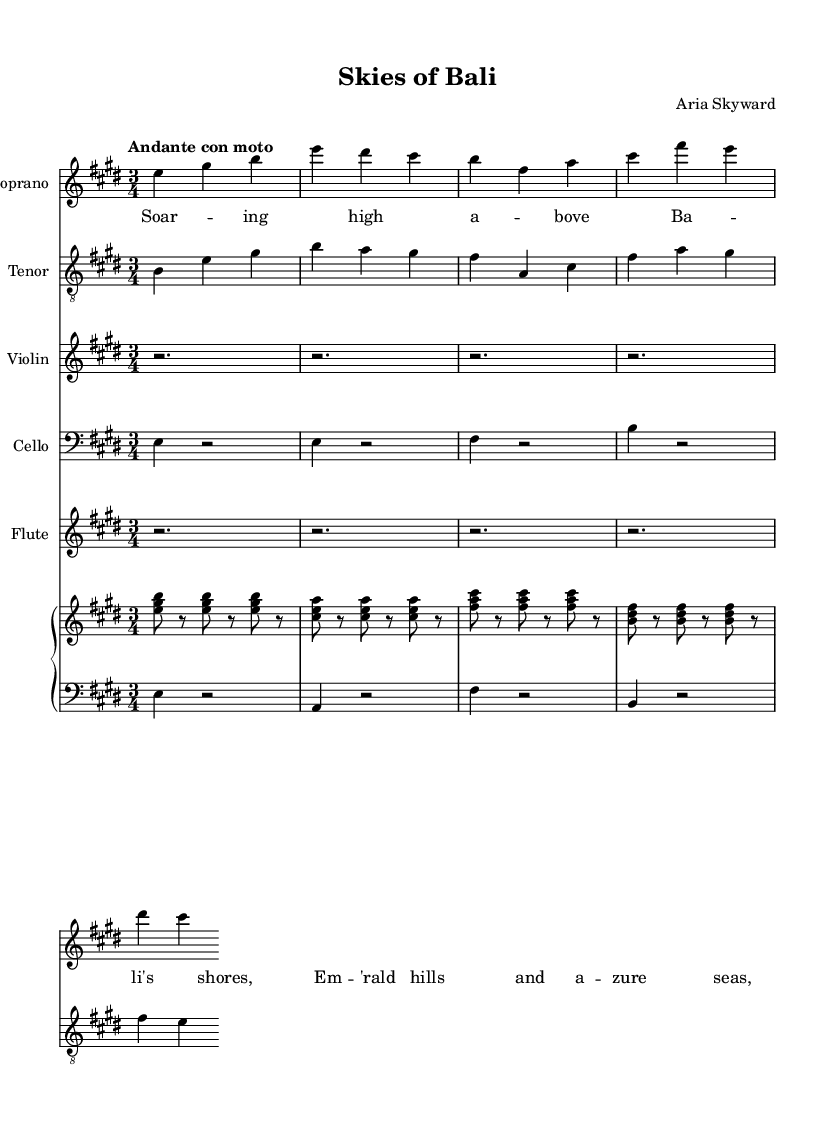What is the key signature of this music? The key signature is E major, which has four sharps (F#, C#, G#, and D#). This is indicated at the beginning of the staff where the sharps are placed.
Answer: E major What is the time signature of this score? The time signature is three-four, indicated by the "3/4" notation at the beginning of the score. This means there are three beats per measure and the quarter note gets the beat.
Answer: 3/4 What tempo marking is indicated in the sheet music? The tempo marking is "Andante con moto," which suggests a moderate tempo with a slight motion. This can be found written in the tempo indication section of the score.
Answer: Andante con moto How many measures are present in the Soprano part? There are four measures in the Soprano part, as indicated by counting the vertical lines that separate the measures. Each segment between the lines is one measure.
Answer: 4 Which instrument plays a rest for all measures shown? The violin plays rests for all measures, indicated by the "r" notation in the score, which signifies that the instrument is silent during these measures.
Answer: Violin What lyrical theme is introduced in the first line of the verse? The lyrical theme introduced is about soaring high above Bali's shores, as stated in the first line of the lyrics. This lyrical content is directly visible in the verse section.
Answer: Soaring high above Bali's shores What is the instrument pairing in the PianoStaff? The instrument pairing is a right hand and left hand piano accompaniment, indicated by the labels "right" and "left" on the respective staves in the PianoStaff.
Answer: Right and left 